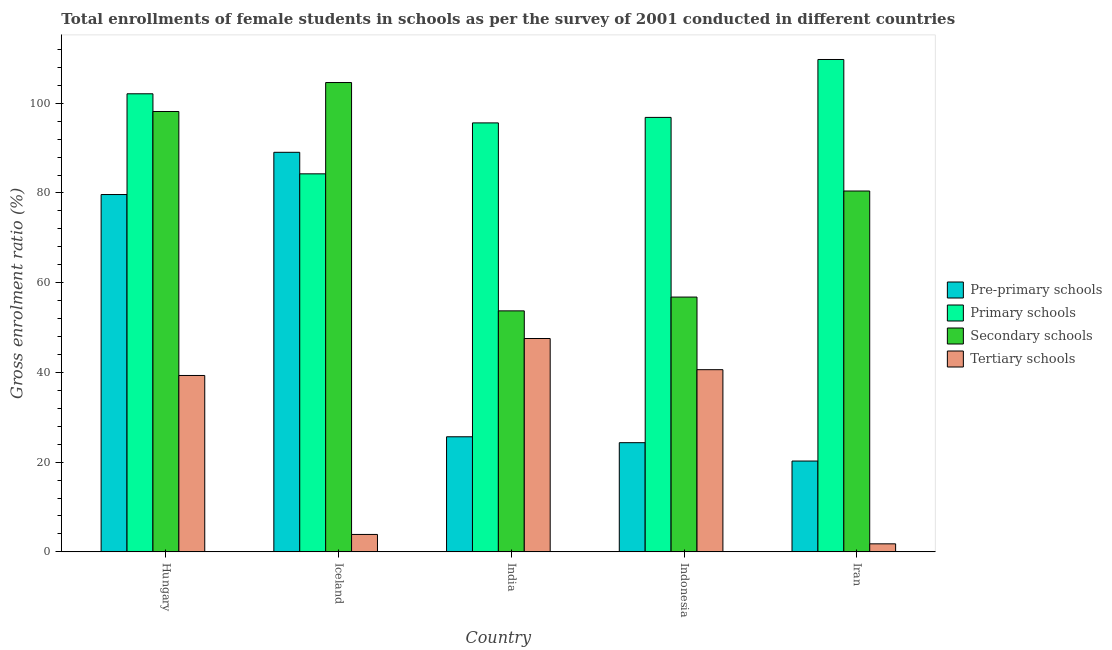How many groups of bars are there?
Give a very brief answer. 5. How many bars are there on the 2nd tick from the right?
Give a very brief answer. 4. What is the label of the 1st group of bars from the left?
Keep it short and to the point. Hungary. In how many cases, is the number of bars for a given country not equal to the number of legend labels?
Your response must be concise. 0. What is the gross enrolment ratio(female) in secondary schools in India?
Your answer should be compact. 53.72. Across all countries, what is the maximum gross enrolment ratio(female) in secondary schools?
Your answer should be compact. 104.61. Across all countries, what is the minimum gross enrolment ratio(female) in secondary schools?
Provide a succinct answer. 53.72. In which country was the gross enrolment ratio(female) in primary schools minimum?
Give a very brief answer. Iceland. What is the total gross enrolment ratio(female) in pre-primary schools in the graph?
Your answer should be very brief. 238.95. What is the difference between the gross enrolment ratio(female) in secondary schools in Hungary and that in Iran?
Your answer should be very brief. 17.73. What is the difference between the gross enrolment ratio(female) in primary schools in Iran and the gross enrolment ratio(female) in tertiary schools in Indonesia?
Keep it short and to the point. 69.14. What is the average gross enrolment ratio(female) in pre-primary schools per country?
Keep it short and to the point. 47.79. What is the difference between the gross enrolment ratio(female) in tertiary schools and gross enrolment ratio(female) in pre-primary schools in Indonesia?
Offer a terse response. 16.27. In how many countries, is the gross enrolment ratio(female) in tertiary schools greater than 28 %?
Provide a short and direct response. 3. What is the ratio of the gross enrolment ratio(female) in primary schools in Indonesia to that in Iran?
Ensure brevity in your answer.  0.88. Is the gross enrolment ratio(female) in tertiary schools in Hungary less than that in India?
Provide a short and direct response. Yes. Is the difference between the gross enrolment ratio(female) in pre-primary schools in Hungary and India greater than the difference between the gross enrolment ratio(female) in primary schools in Hungary and India?
Provide a succinct answer. Yes. What is the difference between the highest and the second highest gross enrolment ratio(female) in pre-primary schools?
Make the answer very short. 9.41. What is the difference between the highest and the lowest gross enrolment ratio(female) in secondary schools?
Keep it short and to the point. 50.89. In how many countries, is the gross enrolment ratio(female) in tertiary schools greater than the average gross enrolment ratio(female) in tertiary schools taken over all countries?
Make the answer very short. 3. Is the sum of the gross enrolment ratio(female) in tertiary schools in Hungary and Indonesia greater than the maximum gross enrolment ratio(female) in primary schools across all countries?
Your response must be concise. No. What does the 2nd bar from the left in India represents?
Make the answer very short. Primary schools. What does the 3rd bar from the right in Iran represents?
Make the answer very short. Primary schools. How many countries are there in the graph?
Your answer should be compact. 5. Does the graph contain any zero values?
Keep it short and to the point. No. Where does the legend appear in the graph?
Ensure brevity in your answer.  Center right. How many legend labels are there?
Make the answer very short. 4. What is the title of the graph?
Your answer should be compact. Total enrollments of female students in schools as per the survey of 2001 conducted in different countries. What is the Gross enrolment ratio (%) of Pre-primary schools in Hungary?
Provide a succinct answer. 79.65. What is the Gross enrolment ratio (%) in Primary schools in Hungary?
Ensure brevity in your answer.  102.1. What is the Gross enrolment ratio (%) in Secondary schools in Hungary?
Provide a short and direct response. 98.16. What is the Gross enrolment ratio (%) in Tertiary schools in Hungary?
Offer a very short reply. 39.32. What is the Gross enrolment ratio (%) of Pre-primary schools in Iceland?
Make the answer very short. 89.06. What is the Gross enrolment ratio (%) in Primary schools in Iceland?
Provide a succinct answer. 84.26. What is the Gross enrolment ratio (%) of Secondary schools in Iceland?
Your response must be concise. 104.61. What is the Gross enrolment ratio (%) of Tertiary schools in Iceland?
Ensure brevity in your answer.  3.88. What is the Gross enrolment ratio (%) in Pre-primary schools in India?
Offer a very short reply. 25.66. What is the Gross enrolment ratio (%) of Primary schools in India?
Provide a short and direct response. 95.62. What is the Gross enrolment ratio (%) of Secondary schools in India?
Offer a terse response. 53.72. What is the Gross enrolment ratio (%) of Tertiary schools in India?
Give a very brief answer. 47.56. What is the Gross enrolment ratio (%) of Pre-primary schools in Indonesia?
Provide a short and direct response. 24.34. What is the Gross enrolment ratio (%) of Primary schools in Indonesia?
Provide a short and direct response. 96.84. What is the Gross enrolment ratio (%) of Secondary schools in Indonesia?
Provide a succinct answer. 56.79. What is the Gross enrolment ratio (%) of Tertiary schools in Indonesia?
Make the answer very short. 40.61. What is the Gross enrolment ratio (%) in Pre-primary schools in Iran?
Your answer should be very brief. 20.25. What is the Gross enrolment ratio (%) of Primary schools in Iran?
Offer a terse response. 109.75. What is the Gross enrolment ratio (%) in Secondary schools in Iran?
Provide a succinct answer. 80.43. What is the Gross enrolment ratio (%) in Tertiary schools in Iran?
Give a very brief answer. 1.79. Across all countries, what is the maximum Gross enrolment ratio (%) in Pre-primary schools?
Your answer should be very brief. 89.06. Across all countries, what is the maximum Gross enrolment ratio (%) of Primary schools?
Ensure brevity in your answer.  109.75. Across all countries, what is the maximum Gross enrolment ratio (%) of Secondary schools?
Your answer should be compact. 104.61. Across all countries, what is the maximum Gross enrolment ratio (%) of Tertiary schools?
Provide a short and direct response. 47.56. Across all countries, what is the minimum Gross enrolment ratio (%) of Pre-primary schools?
Keep it short and to the point. 20.25. Across all countries, what is the minimum Gross enrolment ratio (%) in Primary schools?
Ensure brevity in your answer.  84.26. Across all countries, what is the minimum Gross enrolment ratio (%) of Secondary schools?
Your answer should be very brief. 53.72. Across all countries, what is the minimum Gross enrolment ratio (%) of Tertiary schools?
Your answer should be very brief. 1.79. What is the total Gross enrolment ratio (%) of Pre-primary schools in the graph?
Offer a terse response. 238.95. What is the total Gross enrolment ratio (%) in Primary schools in the graph?
Your answer should be very brief. 488.57. What is the total Gross enrolment ratio (%) in Secondary schools in the graph?
Provide a succinct answer. 393.72. What is the total Gross enrolment ratio (%) of Tertiary schools in the graph?
Your response must be concise. 133.16. What is the difference between the Gross enrolment ratio (%) in Pre-primary schools in Hungary and that in Iceland?
Offer a terse response. -9.41. What is the difference between the Gross enrolment ratio (%) of Primary schools in Hungary and that in Iceland?
Offer a terse response. 17.84. What is the difference between the Gross enrolment ratio (%) in Secondary schools in Hungary and that in Iceland?
Offer a very short reply. -6.45. What is the difference between the Gross enrolment ratio (%) in Tertiary schools in Hungary and that in Iceland?
Offer a very short reply. 35.44. What is the difference between the Gross enrolment ratio (%) of Pre-primary schools in Hungary and that in India?
Your answer should be compact. 53.99. What is the difference between the Gross enrolment ratio (%) of Primary schools in Hungary and that in India?
Your response must be concise. 6.49. What is the difference between the Gross enrolment ratio (%) of Secondary schools in Hungary and that in India?
Provide a short and direct response. 44.44. What is the difference between the Gross enrolment ratio (%) of Tertiary schools in Hungary and that in India?
Provide a succinct answer. -8.24. What is the difference between the Gross enrolment ratio (%) in Pre-primary schools in Hungary and that in Indonesia?
Your response must be concise. 55.31. What is the difference between the Gross enrolment ratio (%) in Primary schools in Hungary and that in Indonesia?
Keep it short and to the point. 5.26. What is the difference between the Gross enrolment ratio (%) of Secondary schools in Hungary and that in Indonesia?
Give a very brief answer. 41.37. What is the difference between the Gross enrolment ratio (%) in Tertiary schools in Hungary and that in Indonesia?
Provide a short and direct response. -1.29. What is the difference between the Gross enrolment ratio (%) in Pre-primary schools in Hungary and that in Iran?
Keep it short and to the point. 59.4. What is the difference between the Gross enrolment ratio (%) in Primary schools in Hungary and that in Iran?
Provide a short and direct response. -7.64. What is the difference between the Gross enrolment ratio (%) of Secondary schools in Hungary and that in Iran?
Provide a succinct answer. 17.73. What is the difference between the Gross enrolment ratio (%) in Tertiary schools in Hungary and that in Iran?
Give a very brief answer. 37.53. What is the difference between the Gross enrolment ratio (%) of Pre-primary schools in Iceland and that in India?
Make the answer very short. 63.41. What is the difference between the Gross enrolment ratio (%) in Primary schools in Iceland and that in India?
Give a very brief answer. -11.36. What is the difference between the Gross enrolment ratio (%) in Secondary schools in Iceland and that in India?
Provide a succinct answer. 50.89. What is the difference between the Gross enrolment ratio (%) in Tertiary schools in Iceland and that in India?
Provide a succinct answer. -43.67. What is the difference between the Gross enrolment ratio (%) of Pre-primary schools in Iceland and that in Indonesia?
Provide a short and direct response. 64.72. What is the difference between the Gross enrolment ratio (%) of Primary schools in Iceland and that in Indonesia?
Give a very brief answer. -12.58. What is the difference between the Gross enrolment ratio (%) in Secondary schools in Iceland and that in Indonesia?
Offer a very short reply. 47.82. What is the difference between the Gross enrolment ratio (%) in Tertiary schools in Iceland and that in Indonesia?
Provide a succinct answer. -36.73. What is the difference between the Gross enrolment ratio (%) in Pre-primary schools in Iceland and that in Iran?
Give a very brief answer. 68.82. What is the difference between the Gross enrolment ratio (%) in Primary schools in Iceland and that in Iran?
Your answer should be very brief. -25.49. What is the difference between the Gross enrolment ratio (%) in Secondary schools in Iceland and that in Iran?
Offer a terse response. 24.18. What is the difference between the Gross enrolment ratio (%) in Tertiary schools in Iceland and that in Iran?
Offer a terse response. 2.09. What is the difference between the Gross enrolment ratio (%) in Pre-primary schools in India and that in Indonesia?
Offer a terse response. 1.32. What is the difference between the Gross enrolment ratio (%) in Primary schools in India and that in Indonesia?
Your answer should be compact. -1.22. What is the difference between the Gross enrolment ratio (%) in Secondary schools in India and that in Indonesia?
Make the answer very short. -3.07. What is the difference between the Gross enrolment ratio (%) in Tertiary schools in India and that in Indonesia?
Make the answer very short. 6.95. What is the difference between the Gross enrolment ratio (%) in Pre-primary schools in India and that in Iran?
Your answer should be compact. 5.41. What is the difference between the Gross enrolment ratio (%) of Primary schools in India and that in Iran?
Provide a short and direct response. -14.13. What is the difference between the Gross enrolment ratio (%) of Secondary schools in India and that in Iran?
Provide a succinct answer. -26.71. What is the difference between the Gross enrolment ratio (%) of Tertiary schools in India and that in Iran?
Ensure brevity in your answer.  45.76. What is the difference between the Gross enrolment ratio (%) in Pre-primary schools in Indonesia and that in Iran?
Offer a terse response. 4.09. What is the difference between the Gross enrolment ratio (%) of Primary schools in Indonesia and that in Iran?
Provide a short and direct response. -12.91. What is the difference between the Gross enrolment ratio (%) in Secondary schools in Indonesia and that in Iran?
Keep it short and to the point. -23.64. What is the difference between the Gross enrolment ratio (%) in Tertiary schools in Indonesia and that in Iran?
Provide a succinct answer. 38.82. What is the difference between the Gross enrolment ratio (%) in Pre-primary schools in Hungary and the Gross enrolment ratio (%) in Primary schools in Iceland?
Provide a short and direct response. -4.61. What is the difference between the Gross enrolment ratio (%) of Pre-primary schools in Hungary and the Gross enrolment ratio (%) of Secondary schools in Iceland?
Your response must be concise. -24.96. What is the difference between the Gross enrolment ratio (%) in Pre-primary schools in Hungary and the Gross enrolment ratio (%) in Tertiary schools in Iceland?
Your answer should be very brief. 75.77. What is the difference between the Gross enrolment ratio (%) in Primary schools in Hungary and the Gross enrolment ratio (%) in Secondary schools in Iceland?
Make the answer very short. -2.51. What is the difference between the Gross enrolment ratio (%) of Primary schools in Hungary and the Gross enrolment ratio (%) of Tertiary schools in Iceland?
Your answer should be very brief. 98.22. What is the difference between the Gross enrolment ratio (%) of Secondary schools in Hungary and the Gross enrolment ratio (%) of Tertiary schools in Iceland?
Your answer should be very brief. 94.28. What is the difference between the Gross enrolment ratio (%) in Pre-primary schools in Hungary and the Gross enrolment ratio (%) in Primary schools in India?
Make the answer very short. -15.97. What is the difference between the Gross enrolment ratio (%) in Pre-primary schools in Hungary and the Gross enrolment ratio (%) in Secondary schools in India?
Offer a very short reply. 25.93. What is the difference between the Gross enrolment ratio (%) in Pre-primary schools in Hungary and the Gross enrolment ratio (%) in Tertiary schools in India?
Your answer should be compact. 32.09. What is the difference between the Gross enrolment ratio (%) of Primary schools in Hungary and the Gross enrolment ratio (%) of Secondary schools in India?
Make the answer very short. 48.38. What is the difference between the Gross enrolment ratio (%) of Primary schools in Hungary and the Gross enrolment ratio (%) of Tertiary schools in India?
Your answer should be very brief. 54.55. What is the difference between the Gross enrolment ratio (%) in Secondary schools in Hungary and the Gross enrolment ratio (%) in Tertiary schools in India?
Your response must be concise. 50.6. What is the difference between the Gross enrolment ratio (%) in Pre-primary schools in Hungary and the Gross enrolment ratio (%) in Primary schools in Indonesia?
Make the answer very short. -17.19. What is the difference between the Gross enrolment ratio (%) in Pre-primary schools in Hungary and the Gross enrolment ratio (%) in Secondary schools in Indonesia?
Offer a terse response. 22.86. What is the difference between the Gross enrolment ratio (%) of Pre-primary schools in Hungary and the Gross enrolment ratio (%) of Tertiary schools in Indonesia?
Make the answer very short. 39.04. What is the difference between the Gross enrolment ratio (%) of Primary schools in Hungary and the Gross enrolment ratio (%) of Secondary schools in Indonesia?
Make the answer very short. 45.31. What is the difference between the Gross enrolment ratio (%) in Primary schools in Hungary and the Gross enrolment ratio (%) in Tertiary schools in Indonesia?
Keep it short and to the point. 61.49. What is the difference between the Gross enrolment ratio (%) in Secondary schools in Hungary and the Gross enrolment ratio (%) in Tertiary schools in Indonesia?
Your answer should be very brief. 57.55. What is the difference between the Gross enrolment ratio (%) in Pre-primary schools in Hungary and the Gross enrolment ratio (%) in Primary schools in Iran?
Keep it short and to the point. -30.1. What is the difference between the Gross enrolment ratio (%) of Pre-primary schools in Hungary and the Gross enrolment ratio (%) of Secondary schools in Iran?
Give a very brief answer. -0.78. What is the difference between the Gross enrolment ratio (%) in Pre-primary schools in Hungary and the Gross enrolment ratio (%) in Tertiary schools in Iran?
Provide a succinct answer. 77.86. What is the difference between the Gross enrolment ratio (%) in Primary schools in Hungary and the Gross enrolment ratio (%) in Secondary schools in Iran?
Your answer should be very brief. 21.67. What is the difference between the Gross enrolment ratio (%) of Primary schools in Hungary and the Gross enrolment ratio (%) of Tertiary schools in Iran?
Keep it short and to the point. 100.31. What is the difference between the Gross enrolment ratio (%) of Secondary schools in Hungary and the Gross enrolment ratio (%) of Tertiary schools in Iran?
Provide a short and direct response. 96.37. What is the difference between the Gross enrolment ratio (%) of Pre-primary schools in Iceland and the Gross enrolment ratio (%) of Primary schools in India?
Make the answer very short. -6.55. What is the difference between the Gross enrolment ratio (%) in Pre-primary schools in Iceland and the Gross enrolment ratio (%) in Secondary schools in India?
Your answer should be compact. 35.34. What is the difference between the Gross enrolment ratio (%) in Pre-primary schools in Iceland and the Gross enrolment ratio (%) in Tertiary schools in India?
Ensure brevity in your answer.  41.51. What is the difference between the Gross enrolment ratio (%) in Primary schools in Iceland and the Gross enrolment ratio (%) in Secondary schools in India?
Offer a terse response. 30.54. What is the difference between the Gross enrolment ratio (%) of Primary schools in Iceland and the Gross enrolment ratio (%) of Tertiary schools in India?
Your answer should be very brief. 36.7. What is the difference between the Gross enrolment ratio (%) in Secondary schools in Iceland and the Gross enrolment ratio (%) in Tertiary schools in India?
Keep it short and to the point. 57.06. What is the difference between the Gross enrolment ratio (%) in Pre-primary schools in Iceland and the Gross enrolment ratio (%) in Primary schools in Indonesia?
Your response must be concise. -7.78. What is the difference between the Gross enrolment ratio (%) in Pre-primary schools in Iceland and the Gross enrolment ratio (%) in Secondary schools in Indonesia?
Ensure brevity in your answer.  32.27. What is the difference between the Gross enrolment ratio (%) of Pre-primary schools in Iceland and the Gross enrolment ratio (%) of Tertiary schools in Indonesia?
Offer a very short reply. 48.45. What is the difference between the Gross enrolment ratio (%) in Primary schools in Iceland and the Gross enrolment ratio (%) in Secondary schools in Indonesia?
Offer a very short reply. 27.47. What is the difference between the Gross enrolment ratio (%) in Primary schools in Iceland and the Gross enrolment ratio (%) in Tertiary schools in Indonesia?
Your answer should be compact. 43.65. What is the difference between the Gross enrolment ratio (%) of Secondary schools in Iceland and the Gross enrolment ratio (%) of Tertiary schools in Indonesia?
Keep it short and to the point. 64. What is the difference between the Gross enrolment ratio (%) in Pre-primary schools in Iceland and the Gross enrolment ratio (%) in Primary schools in Iran?
Your response must be concise. -20.69. What is the difference between the Gross enrolment ratio (%) of Pre-primary schools in Iceland and the Gross enrolment ratio (%) of Secondary schools in Iran?
Make the answer very short. 8.63. What is the difference between the Gross enrolment ratio (%) of Pre-primary schools in Iceland and the Gross enrolment ratio (%) of Tertiary schools in Iran?
Give a very brief answer. 87.27. What is the difference between the Gross enrolment ratio (%) in Primary schools in Iceland and the Gross enrolment ratio (%) in Secondary schools in Iran?
Provide a succinct answer. 3.83. What is the difference between the Gross enrolment ratio (%) in Primary schools in Iceland and the Gross enrolment ratio (%) in Tertiary schools in Iran?
Your response must be concise. 82.47. What is the difference between the Gross enrolment ratio (%) in Secondary schools in Iceland and the Gross enrolment ratio (%) in Tertiary schools in Iran?
Your answer should be very brief. 102.82. What is the difference between the Gross enrolment ratio (%) in Pre-primary schools in India and the Gross enrolment ratio (%) in Primary schools in Indonesia?
Offer a very short reply. -71.19. What is the difference between the Gross enrolment ratio (%) of Pre-primary schools in India and the Gross enrolment ratio (%) of Secondary schools in Indonesia?
Your answer should be compact. -31.14. What is the difference between the Gross enrolment ratio (%) of Pre-primary schools in India and the Gross enrolment ratio (%) of Tertiary schools in Indonesia?
Your response must be concise. -14.95. What is the difference between the Gross enrolment ratio (%) of Primary schools in India and the Gross enrolment ratio (%) of Secondary schools in Indonesia?
Your response must be concise. 38.82. What is the difference between the Gross enrolment ratio (%) in Primary schools in India and the Gross enrolment ratio (%) in Tertiary schools in Indonesia?
Keep it short and to the point. 55.01. What is the difference between the Gross enrolment ratio (%) of Secondary schools in India and the Gross enrolment ratio (%) of Tertiary schools in Indonesia?
Your answer should be compact. 13.11. What is the difference between the Gross enrolment ratio (%) in Pre-primary schools in India and the Gross enrolment ratio (%) in Primary schools in Iran?
Provide a succinct answer. -84.09. What is the difference between the Gross enrolment ratio (%) in Pre-primary schools in India and the Gross enrolment ratio (%) in Secondary schools in Iran?
Make the answer very short. -54.78. What is the difference between the Gross enrolment ratio (%) of Pre-primary schools in India and the Gross enrolment ratio (%) of Tertiary schools in Iran?
Your answer should be compact. 23.86. What is the difference between the Gross enrolment ratio (%) of Primary schools in India and the Gross enrolment ratio (%) of Secondary schools in Iran?
Offer a very short reply. 15.18. What is the difference between the Gross enrolment ratio (%) in Primary schools in India and the Gross enrolment ratio (%) in Tertiary schools in Iran?
Give a very brief answer. 93.82. What is the difference between the Gross enrolment ratio (%) in Secondary schools in India and the Gross enrolment ratio (%) in Tertiary schools in Iran?
Provide a short and direct response. 51.93. What is the difference between the Gross enrolment ratio (%) of Pre-primary schools in Indonesia and the Gross enrolment ratio (%) of Primary schools in Iran?
Give a very brief answer. -85.41. What is the difference between the Gross enrolment ratio (%) of Pre-primary schools in Indonesia and the Gross enrolment ratio (%) of Secondary schools in Iran?
Your response must be concise. -56.09. What is the difference between the Gross enrolment ratio (%) in Pre-primary schools in Indonesia and the Gross enrolment ratio (%) in Tertiary schools in Iran?
Your answer should be compact. 22.55. What is the difference between the Gross enrolment ratio (%) of Primary schools in Indonesia and the Gross enrolment ratio (%) of Secondary schools in Iran?
Offer a very short reply. 16.41. What is the difference between the Gross enrolment ratio (%) in Primary schools in Indonesia and the Gross enrolment ratio (%) in Tertiary schools in Iran?
Your response must be concise. 95.05. What is the difference between the Gross enrolment ratio (%) in Secondary schools in Indonesia and the Gross enrolment ratio (%) in Tertiary schools in Iran?
Ensure brevity in your answer.  55. What is the average Gross enrolment ratio (%) of Pre-primary schools per country?
Provide a short and direct response. 47.79. What is the average Gross enrolment ratio (%) of Primary schools per country?
Make the answer very short. 97.71. What is the average Gross enrolment ratio (%) of Secondary schools per country?
Your response must be concise. 78.74. What is the average Gross enrolment ratio (%) in Tertiary schools per country?
Provide a short and direct response. 26.63. What is the difference between the Gross enrolment ratio (%) in Pre-primary schools and Gross enrolment ratio (%) in Primary schools in Hungary?
Provide a short and direct response. -22.46. What is the difference between the Gross enrolment ratio (%) of Pre-primary schools and Gross enrolment ratio (%) of Secondary schools in Hungary?
Ensure brevity in your answer.  -18.51. What is the difference between the Gross enrolment ratio (%) of Pre-primary schools and Gross enrolment ratio (%) of Tertiary schools in Hungary?
Your answer should be compact. 40.33. What is the difference between the Gross enrolment ratio (%) in Primary schools and Gross enrolment ratio (%) in Secondary schools in Hungary?
Give a very brief answer. 3.94. What is the difference between the Gross enrolment ratio (%) in Primary schools and Gross enrolment ratio (%) in Tertiary schools in Hungary?
Provide a short and direct response. 62.79. What is the difference between the Gross enrolment ratio (%) in Secondary schools and Gross enrolment ratio (%) in Tertiary schools in Hungary?
Give a very brief answer. 58.84. What is the difference between the Gross enrolment ratio (%) of Pre-primary schools and Gross enrolment ratio (%) of Primary schools in Iceland?
Provide a succinct answer. 4.8. What is the difference between the Gross enrolment ratio (%) in Pre-primary schools and Gross enrolment ratio (%) in Secondary schools in Iceland?
Provide a succinct answer. -15.55. What is the difference between the Gross enrolment ratio (%) in Pre-primary schools and Gross enrolment ratio (%) in Tertiary schools in Iceland?
Offer a very short reply. 85.18. What is the difference between the Gross enrolment ratio (%) of Primary schools and Gross enrolment ratio (%) of Secondary schools in Iceland?
Your answer should be compact. -20.35. What is the difference between the Gross enrolment ratio (%) in Primary schools and Gross enrolment ratio (%) in Tertiary schools in Iceland?
Keep it short and to the point. 80.38. What is the difference between the Gross enrolment ratio (%) of Secondary schools and Gross enrolment ratio (%) of Tertiary schools in Iceland?
Your response must be concise. 100.73. What is the difference between the Gross enrolment ratio (%) of Pre-primary schools and Gross enrolment ratio (%) of Primary schools in India?
Your answer should be compact. -69.96. What is the difference between the Gross enrolment ratio (%) of Pre-primary schools and Gross enrolment ratio (%) of Secondary schools in India?
Your response must be concise. -28.07. What is the difference between the Gross enrolment ratio (%) of Pre-primary schools and Gross enrolment ratio (%) of Tertiary schools in India?
Keep it short and to the point. -21.9. What is the difference between the Gross enrolment ratio (%) of Primary schools and Gross enrolment ratio (%) of Secondary schools in India?
Give a very brief answer. 41.9. What is the difference between the Gross enrolment ratio (%) of Primary schools and Gross enrolment ratio (%) of Tertiary schools in India?
Ensure brevity in your answer.  48.06. What is the difference between the Gross enrolment ratio (%) in Secondary schools and Gross enrolment ratio (%) in Tertiary schools in India?
Provide a succinct answer. 6.16. What is the difference between the Gross enrolment ratio (%) of Pre-primary schools and Gross enrolment ratio (%) of Primary schools in Indonesia?
Keep it short and to the point. -72.5. What is the difference between the Gross enrolment ratio (%) of Pre-primary schools and Gross enrolment ratio (%) of Secondary schools in Indonesia?
Give a very brief answer. -32.45. What is the difference between the Gross enrolment ratio (%) in Pre-primary schools and Gross enrolment ratio (%) in Tertiary schools in Indonesia?
Provide a short and direct response. -16.27. What is the difference between the Gross enrolment ratio (%) in Primary schools and Gross enrolment ratio (%) in Secondary schools in Indonesia?
Keep it short and to the point. 40.05. What is the difference between the Gross enrolment ratio (%) in Primary schools and Gross enrolment ratio (%) in Tertiary schools in Indonesia?
Your response must be concise. 56.23. What is the difference between the Gross enrolment ratio (%) of Secondary schools and Gross enrolment ratio (%) of Tertiary schools in Indonesia?
Give a very brief answer. 16.18. What is the difference between the Gross enrolment ratio (%) of Pre-primary schools and Gross enrolment ratio (%) of Primary schools in Iran?
Make the answer very short. -89.5. What is the difference between the Gross enrolment ratio (%) in Pre-primary schools and Gross enrolment ratio (%) in Secondary schools in Iran?
Offer a very short reply. -60.19. What is the difference between the Gross enrolment ratio (%) of Pre-primary schools and Gross enrolment ratio (%) of Tertiary schools in Iran?
Offer a very short reply. 18.46. What is the difference between the Gross enrolment ratio (%) in Primary schools and Gross enrolment ratio (%) in Secondary schools in Iran?
Make the answer very short. 29.32. What is the difference between the Gross enrolment ratio (%) in Primary schools and Gross enrolment ratio (%) in Tertiary schools in Iran?
Give a very brief answer. 107.96. What is the difference between the Gross enrolment ratio (%) of Secondary schools and Gross enrolment ratio (%) of Tertiary schools in Iran?
Ensure brevity in your answer.  78.64. What is the ratio of the Gross enrolment ratio (%) of Pre-primary schools in Hungary to that in Iceland?
Provide a short and direct response. 0.89. What is the ratio of the Gross enrolment ratio (%) of Primary schools in Hungary to that in Iceland?
Provide a succinct answer. 1.21. What is the ratio of the Gross enrolment ratio (%) in Secondary schools in Hungary to that in Iceland?
Make the answer very short. 0.94. What is the ratio of the Gross enrolment ratio (%) of Tertiary schools in Hungary to that in Iceland?
Your answer should be very brief. 10.12. What is the ratio of the Gross enrolment ratio (%) in Pre-primary schools in Hungary to that in India?
Give a very brief answer. 3.1. What is the ratio of the Gross enrolment ratio (%) of Primary schools in Hungary to that in India?
Provide a succinct answer. 1.07. What is the ratio of the Gross enrolment ratio (%) of Secondary schools in Hungary to that in India?
Offer a very short reply. 1.83. What is the ratio of the Gross enrolment ratio (%) of Tertiary schools in Hungary to that in India?
Provide a succinct answer. 0.83. What is the ratio of the Gross enrolment ratio (%) in Pre-primary schools in Hungary to that in Indonesia?
Your answer should be compact. 3.27. What is the ratio of the Gross enrolment ratio (%) in Primary schools in Hungary to that in Indonesia?
Keep it short and to the point. 1.05. What is the ratio of the Gross enrolment ratio (%) in Secondary schools in Hungary to that in Indonesia?
Make the answer very short. 1.73. What is the ratio of the Gross enrolment ratio (%) of Tertiary schools in Hungary to that in Indonesia?
Make the answer very short. 0.97. What is the ratio of the Gross enrolment ratio (%) in Pre-primary schools in Hungary to that in Iran?
Make the answer very short. 3.93. What is the ratio of the Gross enrolment ratio (%) of Primary schools in Hungary to that in Iran?
Ensure brevity in your answer.  0.93. What is the ratio of the Gross enrolment ratio (%) in Secondary schools in Hungary to that in Iran?
Provide a short and direct response. 1.22. What is the ratio of the Gross enrolment ratio (%) in Tertiary schools in Hungary to that in Iran?
Your response must be concise. 21.94. What is the ratio of the Gross enrolment ratio (%) of Pre-primary schools in Iceland to that in India?
Offer a terse response. 3.47. What is the ratio of the Gross enrolment ratio (%) of Primary schools in Iceland to that in India?
Offer a very short reply. 0.88. What is the ratio of the Gross enrolment ratio (%) in Secondary schools in Iceland to that in India?
Provide a short and direct response. 1.95. What is the ratio of the Gross enrolment ratio (%) of Tertiary schools in Iceland to that in India?
Your response must be concise. 0.08. What is the ratio of the Gross enrolment ratio (%) in Pre-primary schools in Iceland to that in Indonesia?
Give a very brief answer. 3.66. What is the ratio of the Gross enrolment ratio (%) of Primary schools in Iceland to that in Indonesia?
Your response must be concise. 0.87. What is the ratio of the Gross enrolment ratio (%) of Secondary schools in Iceland to that in Indonesia?
Make the answer very short. 1.84. What is the ratio of the Gross enrolment ratio (%) in Tertiary schools in Iceland to that in Indonesia?
Offer a very short reply. 0.1. What is the ratio of the Gross enrolment ratio (%) in Pre-primary schools in Iceland to that in Iran?
Your response must be concise. 4.4. What is the ratio of the Gross enrolment ratio (%) of Primary schools in Iceland to that in Iran?
Provide a short and direct response. 0.77. What is the ratio of the Gross enrolment ratio (%) in Secondary schools in Iceland to that in Iran?
Make the answer very short. 1.3. What is the ratio of the Gross enrolment ratio (%) of Tertiary schools in Iceland to that in Iran?
Give a very brief answer. 2.17. What is the ratio of the Gross enrolment ratio (%) in Pre-primary schools in India to that in Indonesia?
Keep it short and to the point. 1.05. What is the ratio of the Gross enrolment ratio (%) of Primary schools in India to that in Indonesia?
Provide a succinct answer. 0.99. What is the ratio of the Gross enrolment ratio (%) of Secondary schools in India to that in Indonesia?
Provide a short and direct response. 0.95. What is the ratio of the Gross enrolment ratio (%) in Tertiary schools in India to that in Indonesia?
Offer a terse response. 1.17. What is the ratio of the Gross enrolment ratio (%) in Pre-primary schools in India to that in Iran?
Your response must be concise. 1.27. What is the ratio of the Gross enrolment ratio (%) in Primary schools in India to that in Iran?
Offer a very short reply. 0.87. What is the ratio of the Gross enrolment ratio (%) of Secondary schools in India to that in Iran?
Your response must be concise. 0.67. What is the ratio of the Gross enrolment ratio (%) of Tertiary schools in India to that in Iran?
Ensure brevity in your answer.  26.54. What is the ratio of the Gross enrolment ratio (%) in Pre-primary schools in Indonesia to that in Iran?
Offer a terse response. 1.2. What is the ratio of the Gross enrolment ratio (%) of Primary schools in Indonesia to that in Iran?
Ensure brevity in your answer.  0.88. What is the ratio of the Gross enrolment ratio (%) in Secondary schools in Indonesia to that in Iran?
Your answer should be compact. 0.71. What is the ratio of the Gross enrolment ratio (%) of Tertiary schools in Indonesia to that in Iran?
Offer a very short reply. 22.66. What is the difference between the highest and the second highest Gross enrolment ratio (%) of Pre-primary schools?
Offer a very short reply. 9.41. What is the difference between the highest and the second highest Gross enrolment ratio (%) of Primary schools?
Ensure brevity in your answer.  7.64. What is the difference between the highest and the second highest Gross enrolment ratio (%) in Secondary schools?
Your response must be concise. 6.45. What is the difference between the highest and the second highest Gross enrolment ratio (%) of Tertiary schools?
Ensure brevity in your answer.  6.95. What is the difference between the highest and the lowest Gross enrolment ratio (%) in Pre-primary schools?
Ensure brevity in your answer.  68.82. What is the difference between the highest and the lowest Gross enrolment ratio (%) of Primary schools?
Provide a succinct answer. 25.49. What is the difference between the highest and the lowest Gross enrolment ratio (%) of Secondary schools?
Provide a short and direct response. 50.89. What is the difference between the highest and the lowest Gross enrolment ratio (%) of Tertiary schools?
Provide a short and direct response. 45.76. 